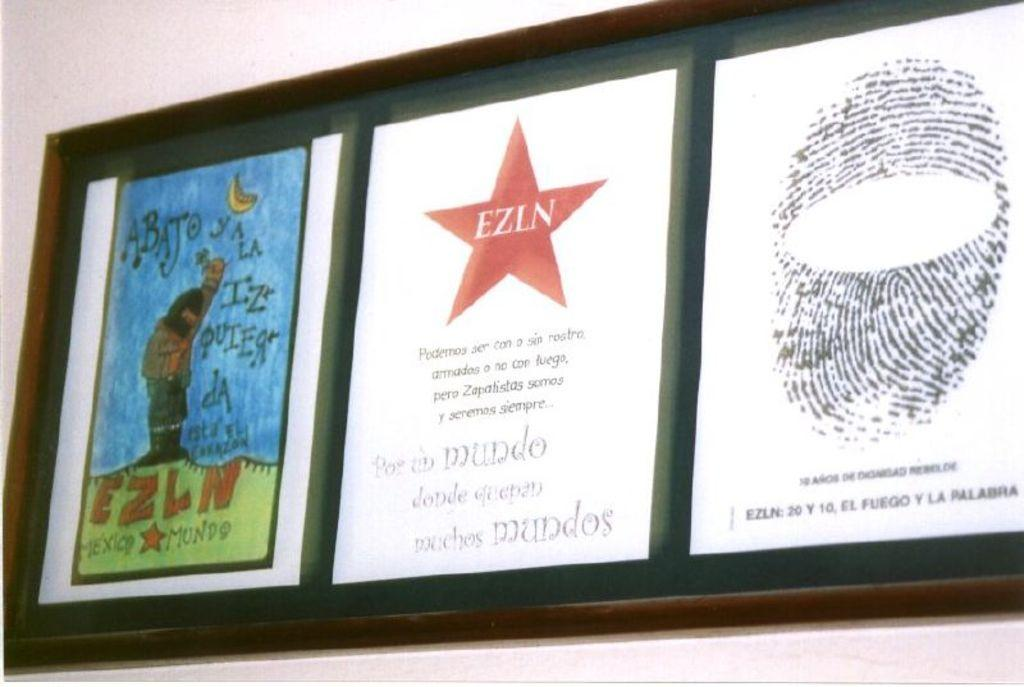<image>
Give a short and clear explanation of the subsequent image. A framed picture with a red star, with the letters EZLN. 